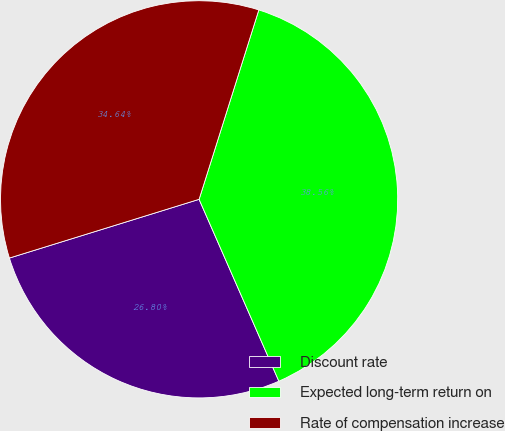Convert chart. <chart><loc_0><loc_0><loc_500><loc_500><pie_chart><fcel>Discount rate<fcel>Expected long-term return on<fcel>Rate of compensation increase<nl><fcel>26.8%<fcel>38.56%<fcel>34.64%<nl></chart> 